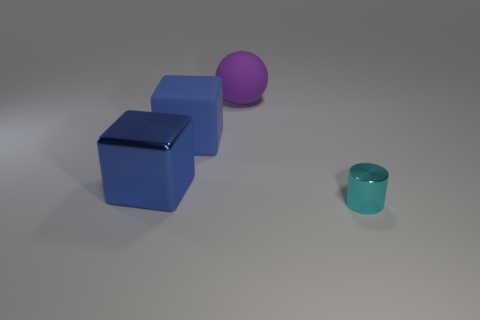Add 2 big matte balls. How many objects exist? 6 Add 2 tiny things. How many tiny things are left? 3 Add 1 metal objects. How many metal objects exist? 3 Subtract 0 brown blocks. How many objects are left? 4 Subtract all tiny cyan metal objects. Subtract all matte blocks. How many objects are left? 2 